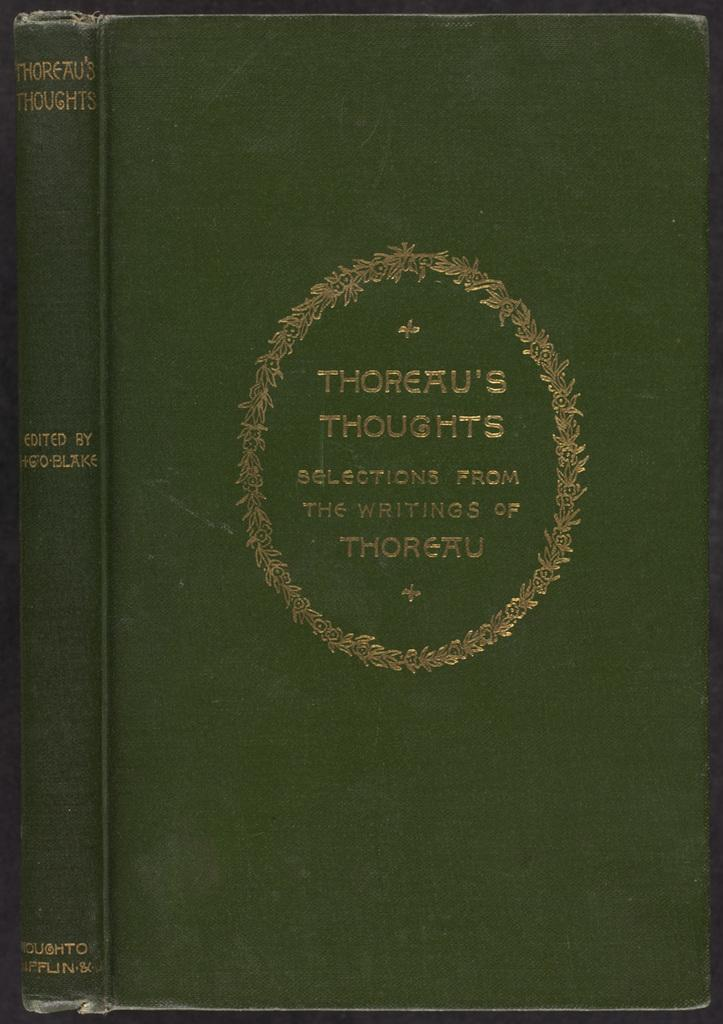<image>
Give a short and clear explanation of the subsequent image. A green slightly frayed book titled Thoreau's thoughts 